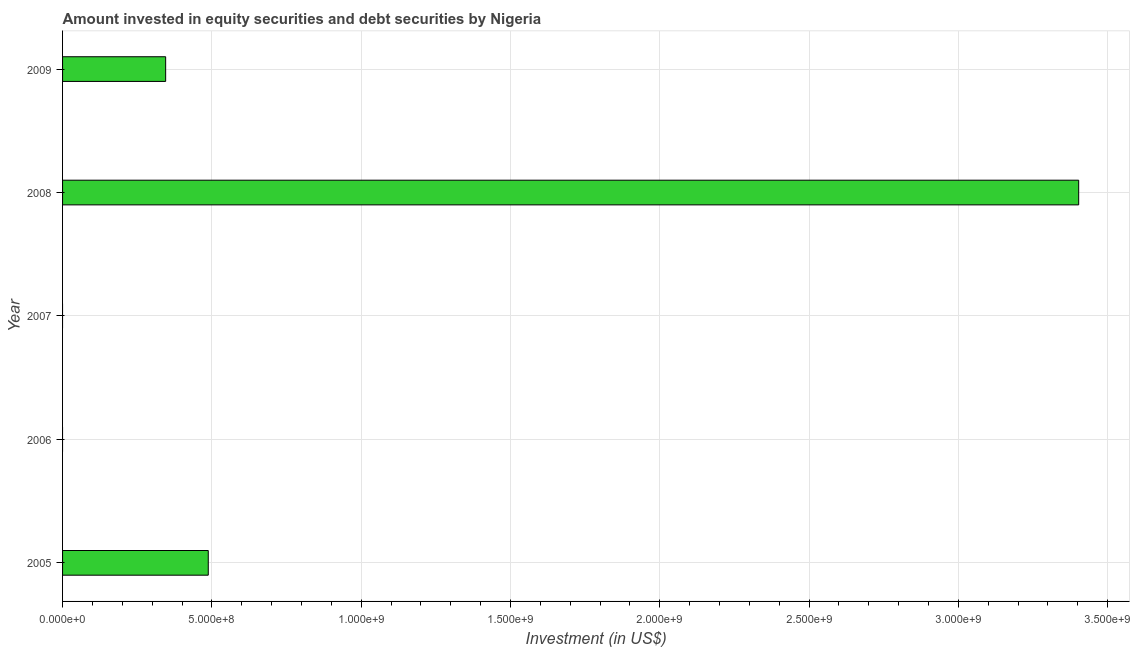What is the title of the graph?
Make the answer very short. Amount invested in equity securities and debt securities by Nigeria. What is the label or title of the X-axis?
Offer a terse response. Investment (in US$). What is the portfolio investment in 2008?
Ensure brevity in your answer.  3.40e+09. Across all years, what is the maximum portfolio investment?
Make the answer very short. 3.40e+09. Across all years, what is the minimum portfolio investment?
Provide a short and direct response. 0. What is the sum of the portfolio investment?
Make the answer very short. 4.24e+09. What is the difference between the portfolio investment in 2005 and 2008?
Make the answer very short. -2.91e+09. What is the average portfolio investment per year?
Give a very brief answer. 8.47e+08. What is the median portfolio investment?
Keep it short and to the point. 3.45e+08. What is the ratio of the portfolio investment in 2005 to that in 2009?
Make the answer very short. 1.41. Is the portfolio investment in 2005 less than that in 2008?
Give a very brief answer. Yes. Is the difference between the portfolio investment in 2008 and 2009 greater than the difference between any two years?
Your answer should be very brief. No. What is the difference between the highest and the second highest portfolio investment?
Offer a very short reply. 2.91e+09. Is the sum of the portfolio investment in 2008 and 2009 greater than the maximum portfolio investment across all years?
Ensure brevity in your answer.  Yes. What is the difference between the highest and the lowest portfolio investment?
Your answer should be very brief. 3.40e+09. How many bars are there?
Provide a short and direct response. 3. Are all the bars in the graph horizontal?
Ensure brevity in your answer.  Yes. How many years are there in the graph?
Your response must be concise. 5. What is the difference between two consecutive major ticks on the X-axis?
Give a very brief answer. 5.00e+08. What is the Investment (in US$) in 2005?
Keep it short and to the point. 4.88e+08. What is the Investment (in US$) of 2006?
Make the answer very short. 0. What is the Investment (in US$) of 2007?
Make the answer very short. 0. What is the Investment (in US$) in 2008?
Your answer should be very brief. 3.40e+09. What is the Investment (in US$) in 2009?
Keep it short and to the point. 3.45e+08. What is the difference between the Investment (in US$) in 2005 and 2008?
Ensure brevity in your answer.  -2.91e+09. What is the difference between the Investment (in US$) in 2005 and 2009?
Provide a short and direct response. 1.43e+08. What is the difference between the Investment (in US$) in 2008 and 2009?
Offer a terse response. 3.06e+09. What is the ratio of the Investment (in US$) in 2005 to that in 2008?
Keep it short and to the point. 0.14. What is the ratio of the Investment (in US$) in 2005 to that in 2009?
Make the answer very short. 1.41. What is the ratio of the Investment (in US$) in 2008 to that in 2009?
Provide a succinct answer. 9.86. 